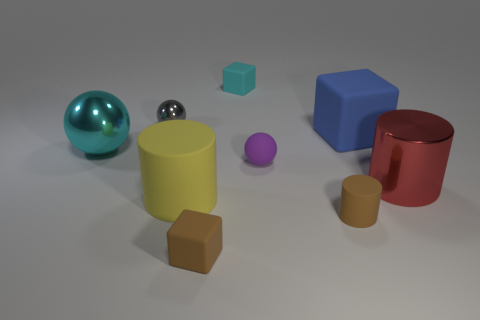Are there any other things that are the same material as the large yellow cylinder?
Your answer should be compact. Yes. There is another tiny object that is the same shape as the red metallic thing; what is its material?
Give a very brief answer. Rubber. Are there fewer tiny cubes behind the big red metal cylinder than big purple matte cylinders?
Your answer should be very brief. No. There is a large red metallic cylinder; how many tiny purple things are on the right side of it?
Keep it short and to the point. 0. Does the tiny matte object that is behind the large blue cube have the same shape as the large rubber thing behind the cyan ball?
Provide a short and direct response. Yes. What is the shape of the tiny rubber thing that is both left of the purple object and in front of the matte ball?
Your answer should be compact. Cube. What size is the cyan object that is made of the same material as the red cylinder?
Your answer should be very brief. Large. Is the number of big yellow things less than the number of brown matte things?
Offer a very short reply. Yes. What is the big cylinder right of the small rubber cube in front of the big cylinder on the left side of the tiny brown rubber cylinder made of?
Your answer should be very brief. Metal. Is the cyan object in front of the tiny gray shiny thing made of the same material as the cyan thing that is right of the gray object?
Ensure brevity in your answer.  No. 